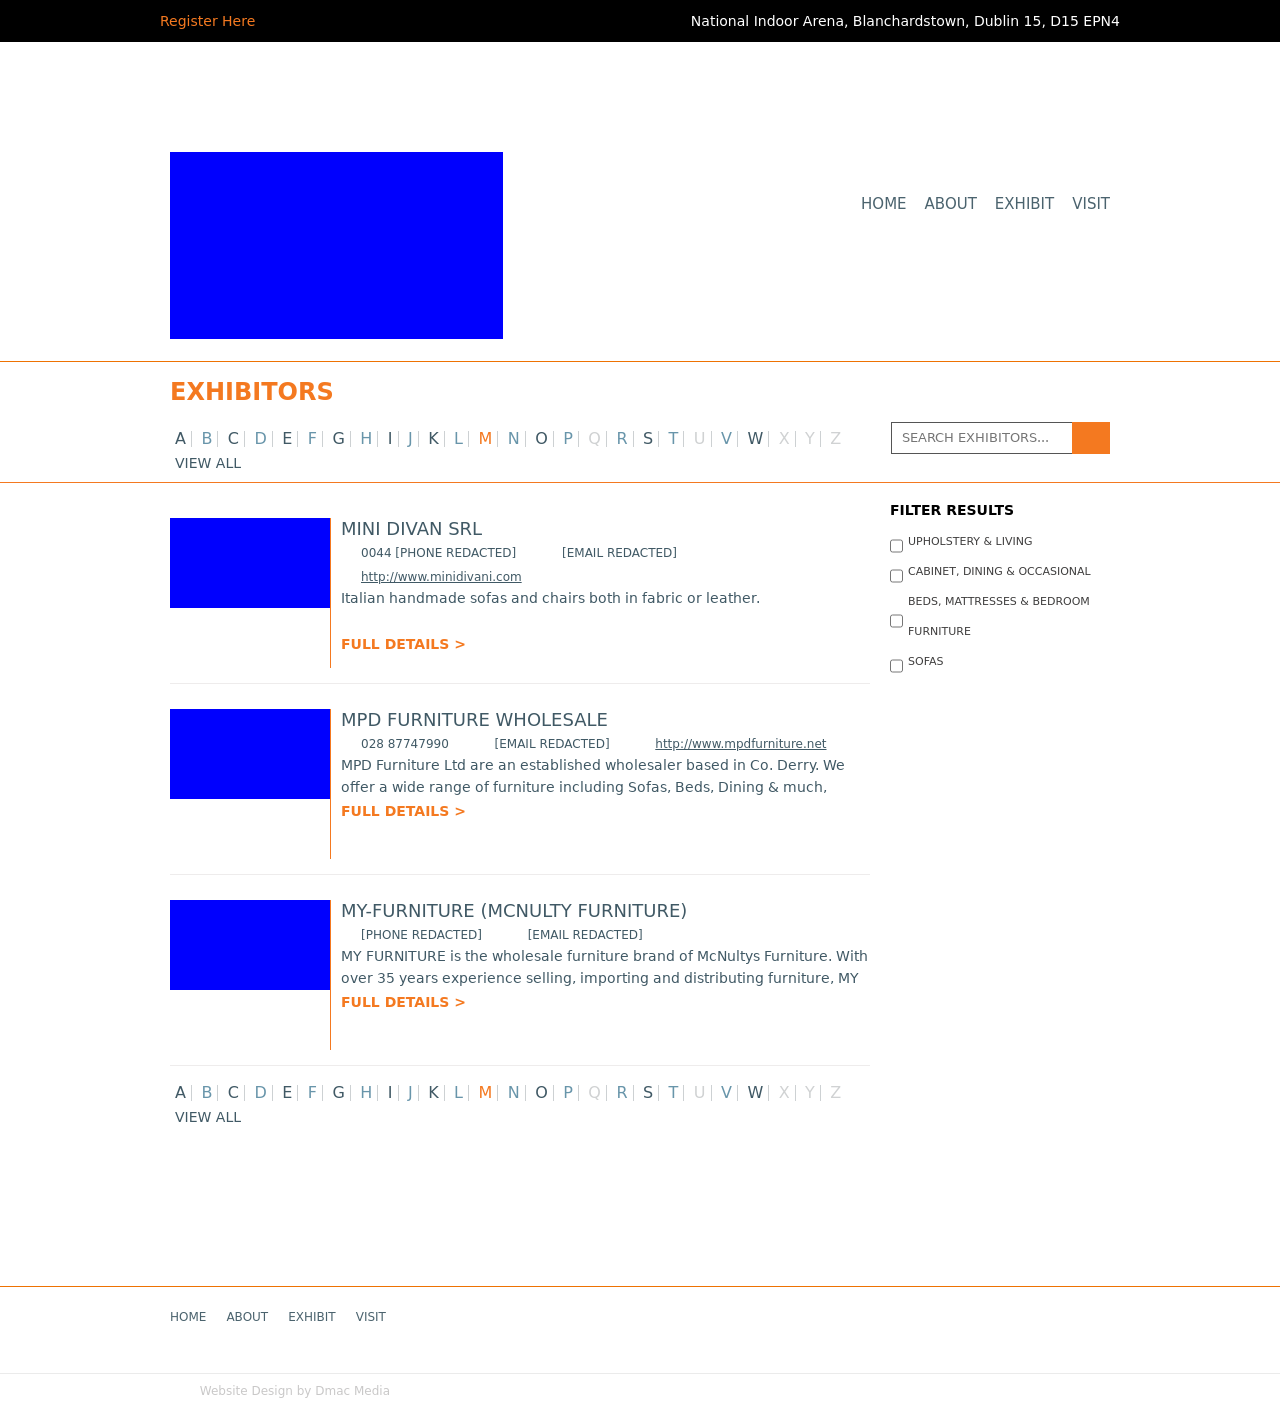Can you describe the layout presented in this image for the website section? Certainly! The image displays a web page section where exhibitors are listed. There's a clear header titled 'EXHIBITORS' and an alphabetical filter for quick navigation. Below, each exhibitor has a dedicated entry featuring a placeholder image, company name, contact information, a brief description, and a link for full details. The layout is clean and user-friendly, designed for easy browsing.  How can the design be improved to enhance usability? To enhance usability, consider adding hover effects on buttons for better visual feedback. Improve readability with larger fonts for critical information like contact details. A search function could be implemented for finding exhibitors by name or category. Ensuring responsive design will also improve the experience on mobile devices. 